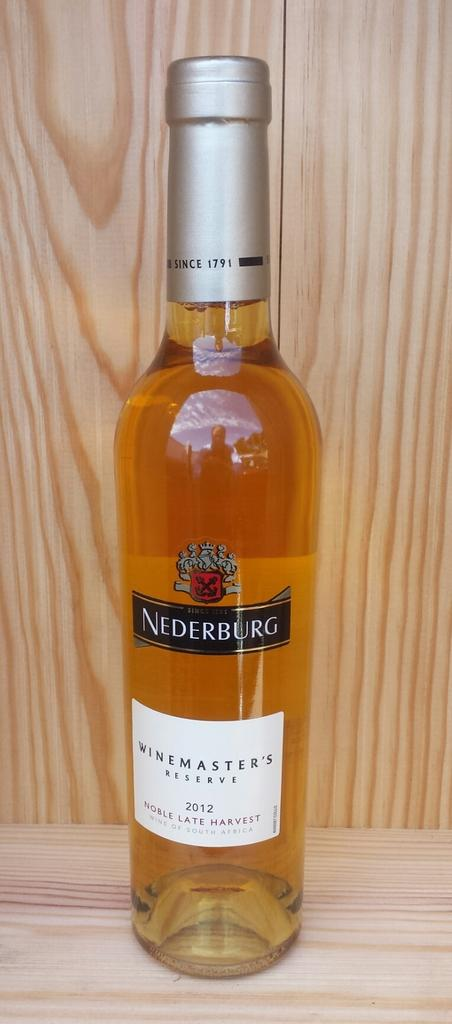What object can be seen in the image? There is a bottle in the image. What is unique about the bottle? The bottle has a label. Where is the bottle located? The bottle is placed on a wooden table. What can be seen in the background of the image? There is a wooden wall in the background of the image. How many legs does the bottle have in the image? Bottles do not have legs, so this question cannot be answered. 